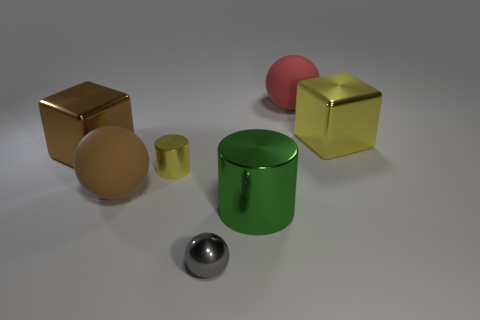Is the number of rubber objects greater than the number of metallic balls?
Ensure brevity in your answer.  Yes. There is a small object that is on the left side of the tiny metallic object in front of the large matte object that is on the left side of the small yellow cylinder; what is it made of?
Keep it short and to the point. Metal. Does the small cylinder have the same color as the big metal cylinder?
Give a very brief answer. No. Is there a cylinder that has the same color as the shiny ball?
Your response must be concise. No. There is a red matte thing that is the same size as the brown rubber thing; what shape is it?
Ensure brevity in your answer.  Sphere. Are there fewer yellow metal cubes than small gray cubes?
Offer a terse response. No. What number of green metal objects are the same size as the brown metal cube?
Provide a short and direct response. 1. The big object that is the same color as the tiny metallic cylinder is what shape?
Ensure brevity in your answer.  Cube. What material is the small gray object?
Provide a succinct answer. Metal. There is a rubber object that is on the left side of the tiny gray metallic ball; how big is it?
Give a very brief answer. Large. 